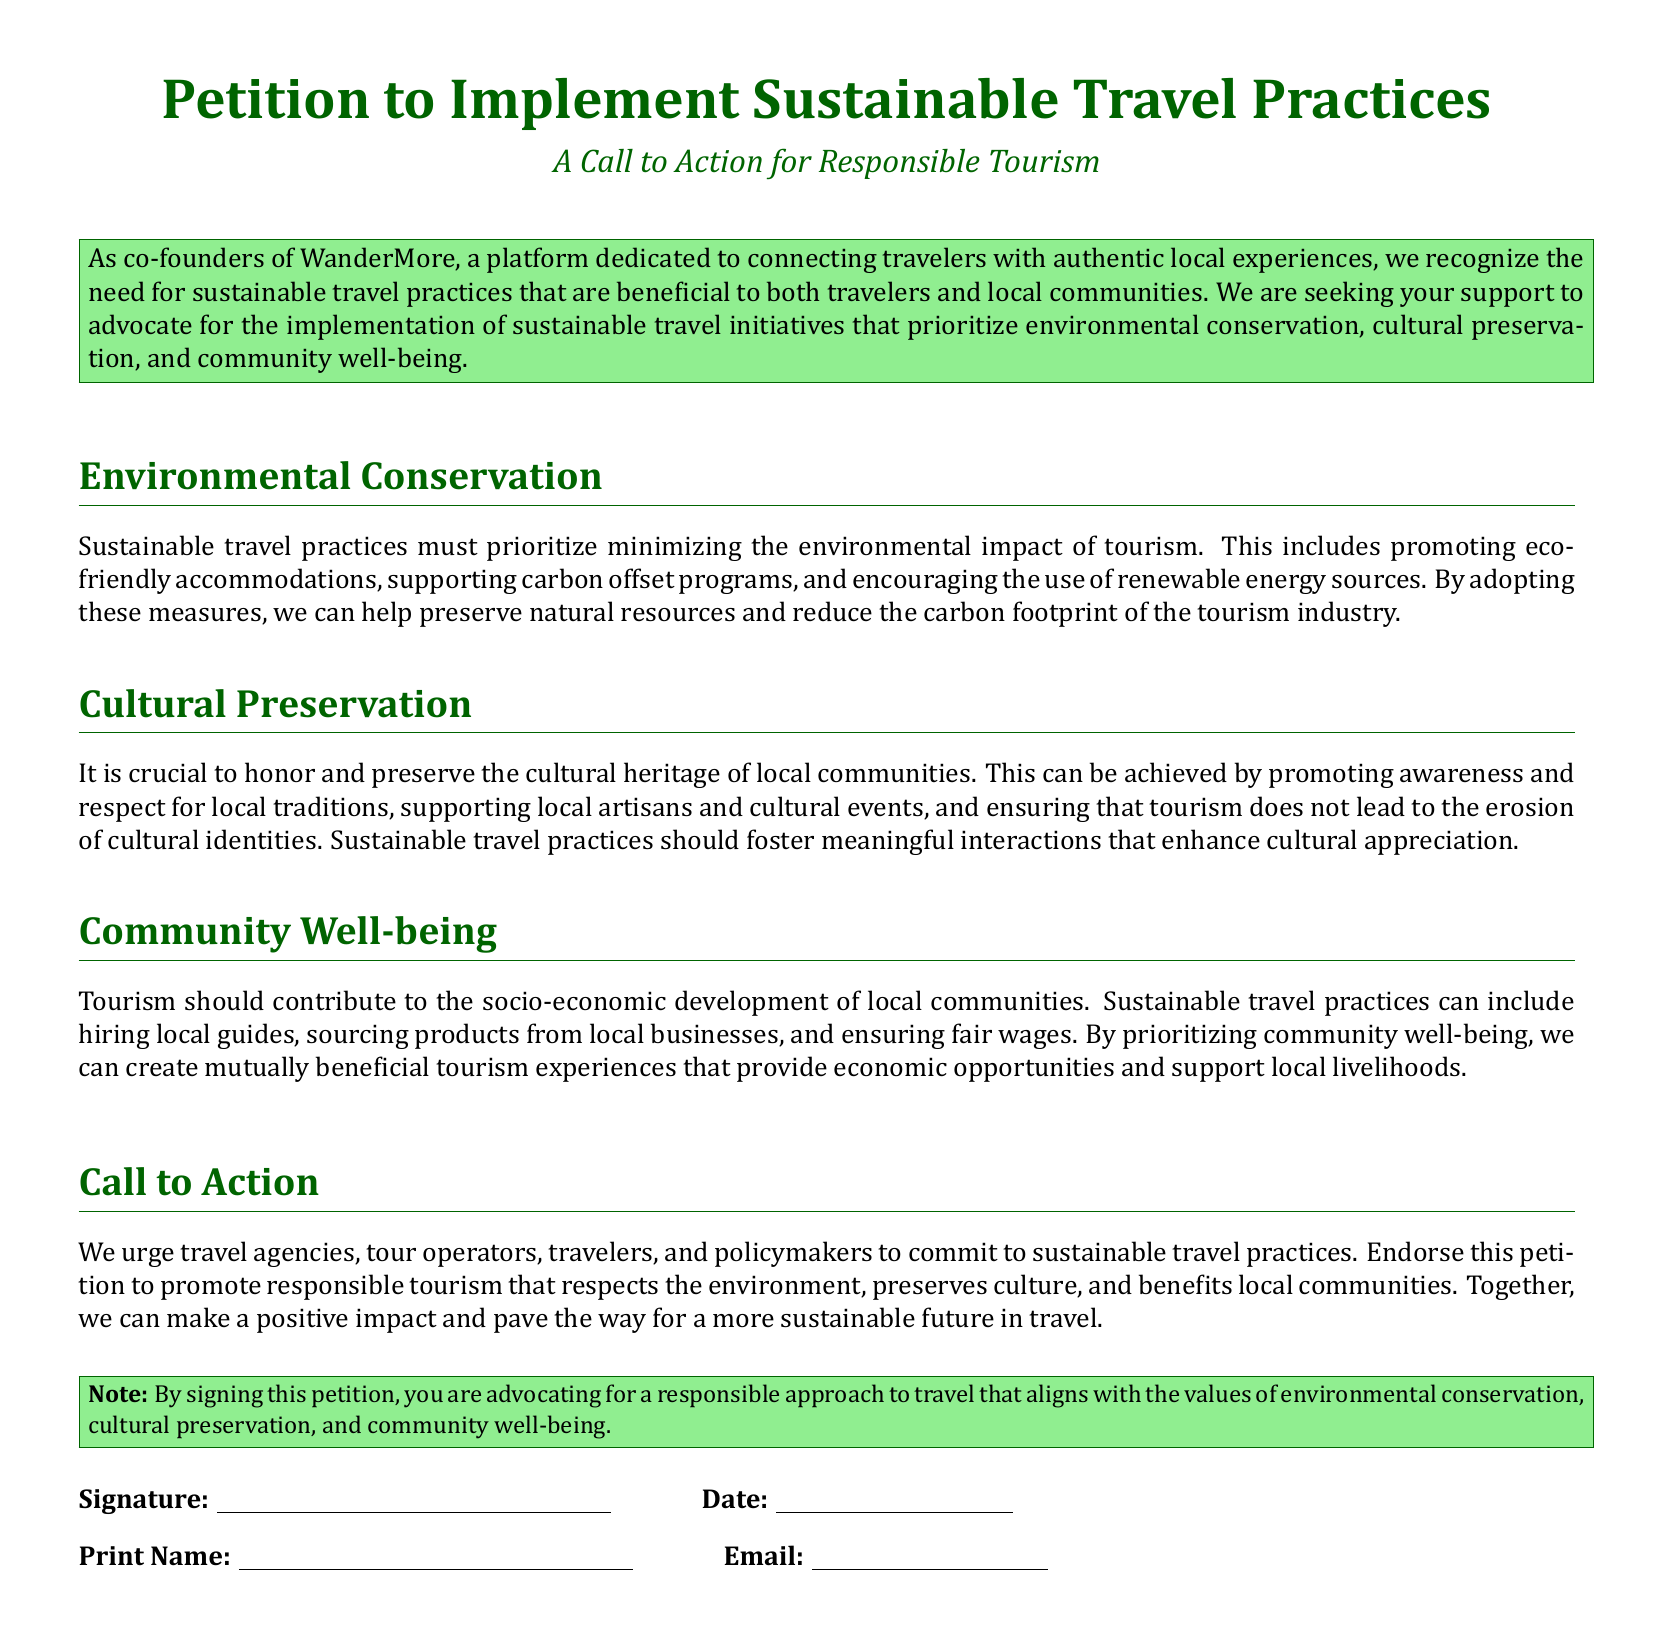What is the title of the petition? The title is prominently displayed at the beginning of the document, stating the intent of the petition.
Answer: Petition to Implement Sustainable Travel Practices Who are the co-founders of WanderMore? The document mentions the co-founders but does not specify individual names, focusing instead on the platform's mission.
Answer: WanderMore What does the petition prioritize in terms of travel practices? The petition emphasizes several key areas that sustainable travel practices should focus on, which are listed in the document.
Answer: Environmental conservation, cultural preservation, community well-being What should tourism contribute to according to the petition? The petition outlines the socio-economic aspect of tourism, which is vital for local communities.
Answer: Socio-economic development What color is used for the title? The document uses a specific color for the title which is consistent throughout.
Answer: Dark green What does signing the petition advocate for? The document clearly states the purpose of signing the petition, highlighting what values it supports.
Answer: A responsible approach to travel What is mentioned as a practice to support community well-being? The document provides specific suggestions to enhance local community benefits through tourism.
Answer: Hiring local guides What type of businesses should be sourced from according to the petition? The petition emphasizes the importance of supporting local economies through specific types of businesses.
Answer: Local businesses What is included in the signature section? The document includes necessary fields for participants to formally endorse the petition.
Answer: Signature, date, print name, email 